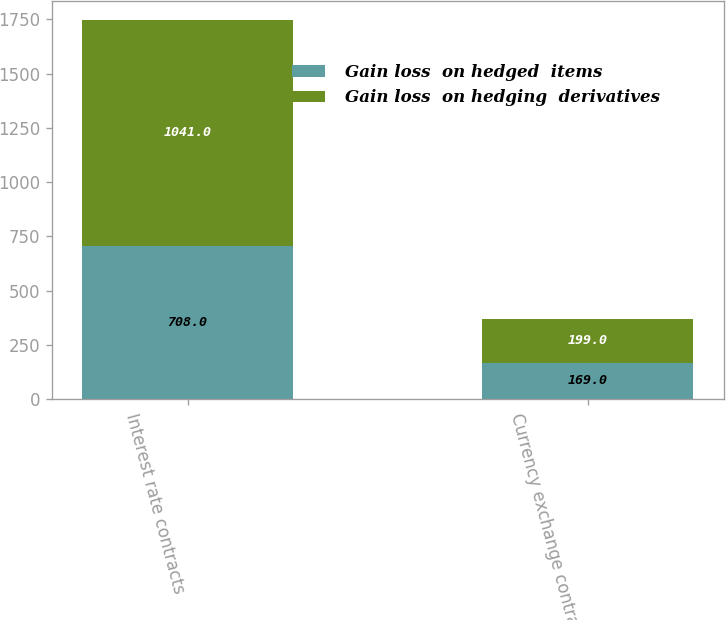<chart> <loc_0><loc_0><loc_500><loc_500><stacked_bar_chart><ecel><fcel>Interest rate contracts<fcel>Currency exchange contracts<nl><fcel>Gain loss  on hedged  items<fcel>708<fcel>169<nl><fcel>Gain loss  on hedging  derivatives<fcel>1041<fcel>199<nl></chart> 